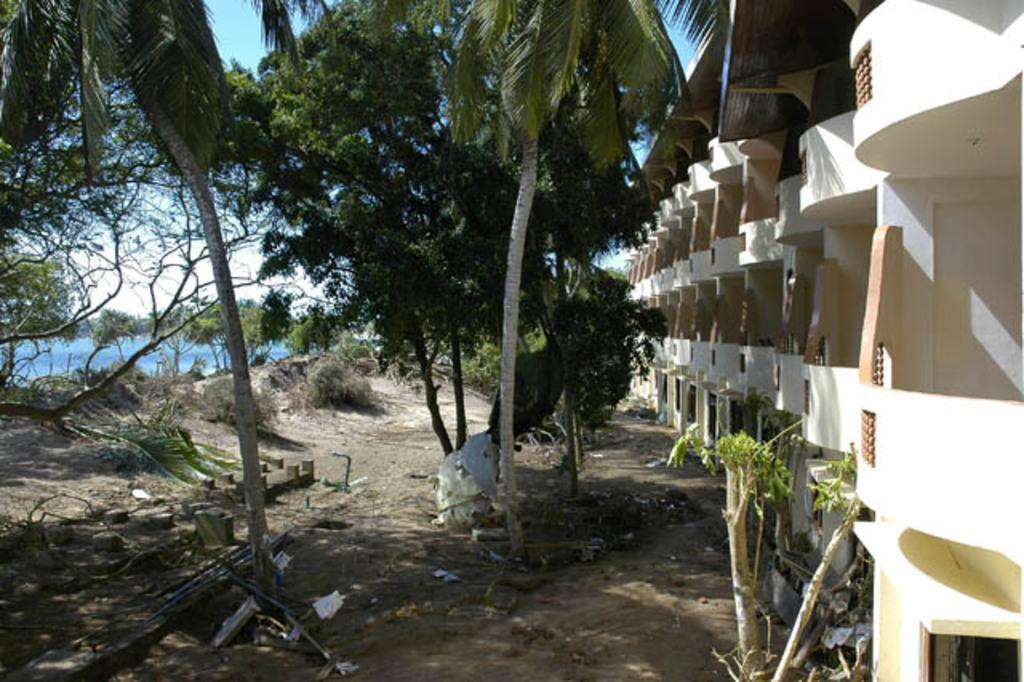What type of terrain is on the left side of the image? There is water on the left side of the image. What can be found in the middle of the image? There is sand and a group of trees in the middle of the image. What type of structure is on the right side of the image? There is a building on the right side of the image. What type of gold can be seen in the image? There is no gold present in the image. What route is visible in the image? There is no route visible in the image. 